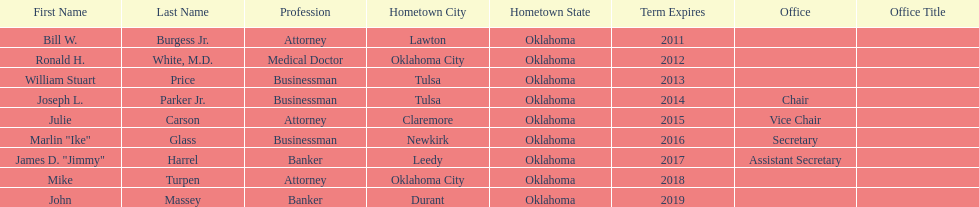Who are the regents? Bill W. Burgess Jr., Ronald H. White, M.D., William Stuart Price, Joseph L. Parker Jr., Julie Carson, Marlin "Ike" Glass, James D. "Jimmy" Harrel, Mike Turpen, John Massey. Of these who is a businessman? William Stuart Price, Joseph L. Parker Jr., Marlin "Ike" Glass. Of these whose hometown is tulsa? William Stuart Price, Joseph L. Parker Jr. Of these whose term expires in 2013? William Stuart Price. 